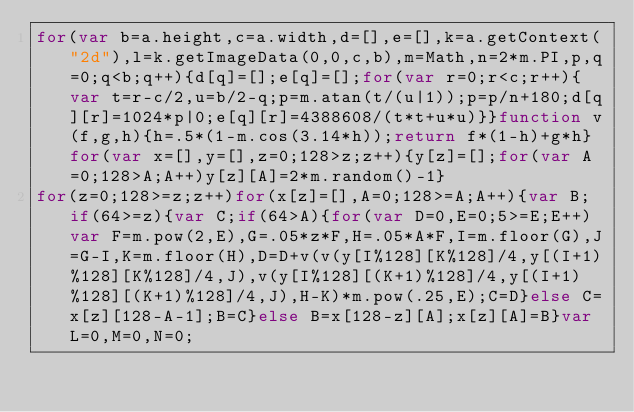<code> <loc_0><loc_0><loc_500><loc_500><_JavaScript_>for(var b=a.height,c=a.width,d=[],e=[],k=a.getContext("2d"),l=k.getImageData(0,0,c,b),m=Math,n=2*m.PI,p,q=0;q<b;q++){d[q]=[];e[q]=[];for(var r=0;r<c;r++){var t=r-c/2,u=b/2-q;p=m.atan(t/(u|1));p=p/n+180;d[q][r]=1024*p|0;e[q][r]=4388608/(t*t+u*u)}}function v(f,g,h){h=.5*(1-m.cos(3.14*h));return f*(1-h)+g*h}for(var x=[],y=[],z=0;128>z;z++){y[z]=[];for(var A=0;128>A;A++)y[z][A]=2*m.random()-1}
for(z=0;128>=z;z++)for(x[z]=[],A=0;128>=A;A++){var B;if(64>=z){var C;if(64>A){for(var D=0,E=0;5>=E;E++)var F=m.pow(2,E),G=.05*z*F,H=.05*A*F,I=m.floor(G),J=G-I,K=m.floor(H),D=D+v(v(y[I%128][K%128]/4,y[(I+1)%128][K%128]/4,J),v(y[I%128][(K+1)%128]/4,y[(I+1)%128][(K+1)%128]/4,J),H-K)*m.pow(.25,E);C=D}else C=x[z][128-A-1];B=C}else B=x[128-z][A];x[z][A]=B}var L=0,M=0,N=0;</code> 